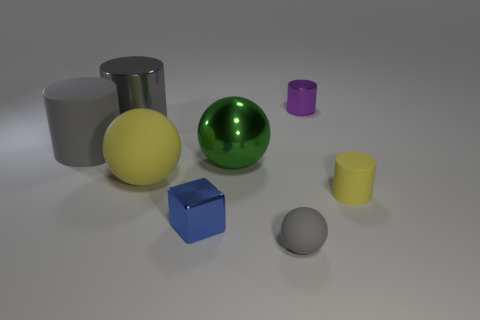Subtract 1 cylinders. How many cylinders are left? 3 Add 1 tiny yellow things. How many objects exist? 9 Subtract all balls. How many objects are left? 5 Add 4 metal balls. How many metal balls exist? 5 Subtract 0 red balls. How many objects are left? 8 Subtract all small purple rubber cylinders. Subtract all small purple objects. How many objects are left? 7 Add 1 big gray matte things. How many big gray matte things are left? 2 